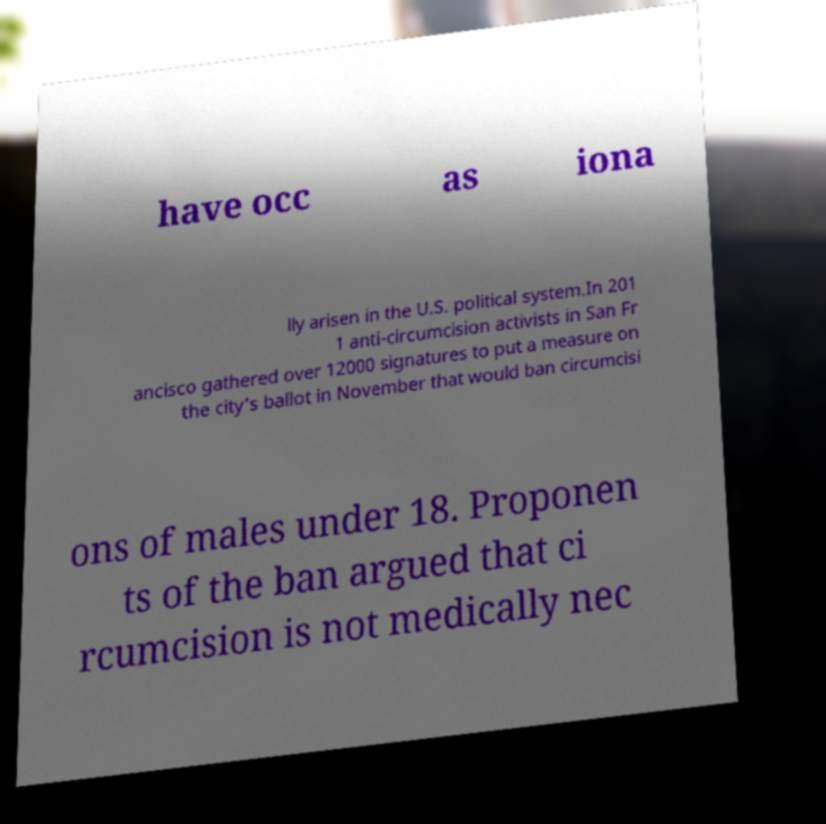Can you read and provide the text displayed in the image?This photo seems to have some interesting text. Can you extract and type it out for me? have occ as iona lly arisen in the U.S. political system.In 201 1 anti-circumcision activists in San Fr ancisco gathered over 12000 signatures to put a measure on the city's ballot in November that would ban circumcisi ons of males under 18. Proponen ts of the ban argued that ci rcumcision is not medically nec 